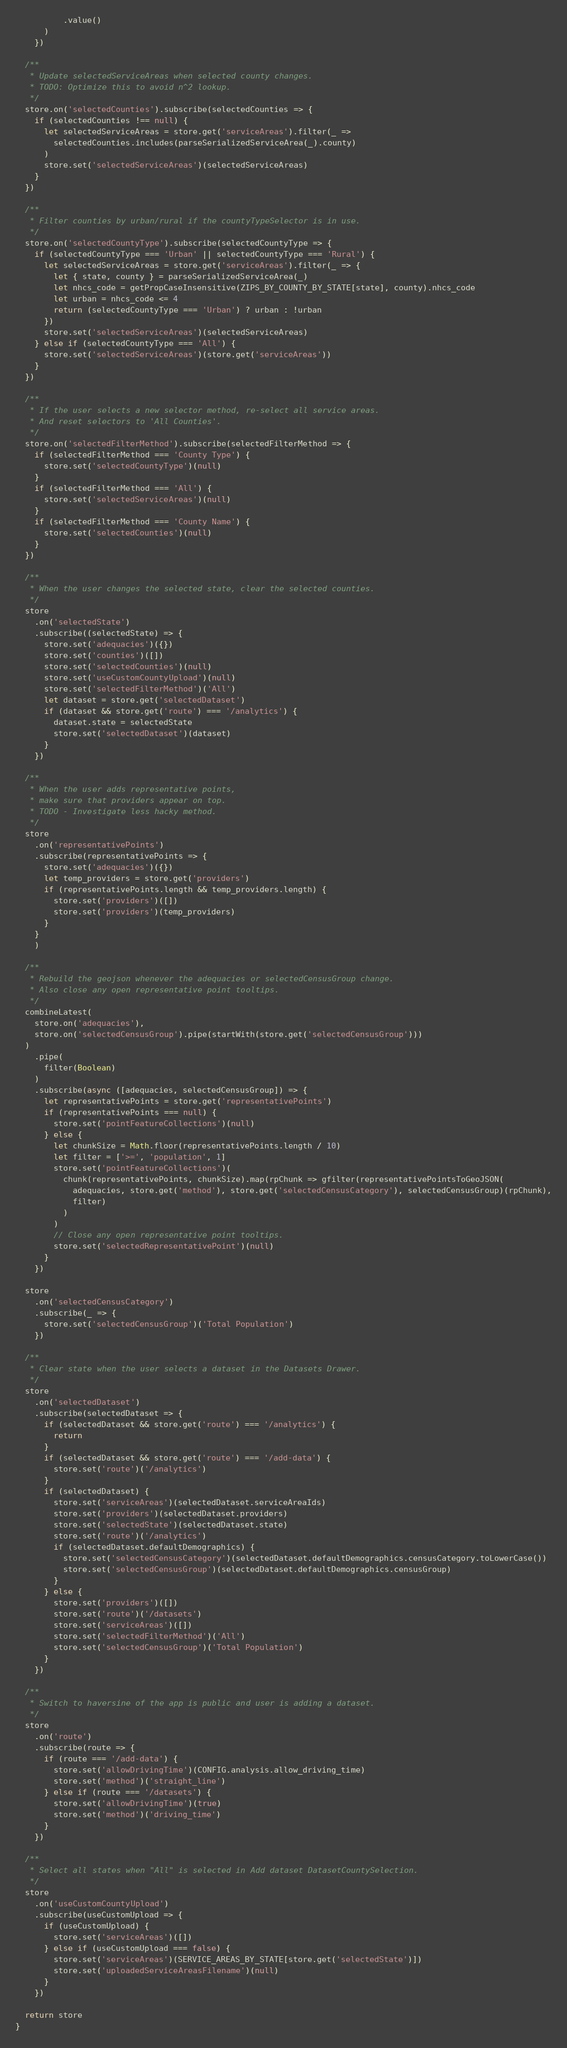Convert code to text. <code><loc_0><loc_0><loc_500><loc_500><_TypeScript_>          .value()
      )
    })

  /**
   * Update selectedServiceAreas when selected county changes.
   * TODO: Optimize this to avoid n^2 lookup.
   */
  store.on('selectedCounties').subscribe(selectedCounties => {
    if (selectedCounties !== null) {
      let selectedServiceAreas = store.get('serviceAreas').filter(_ =>
        selectedCounties.includes(parseSerializedServiceArea(_).county)
      )
      store.set('selectedServiceAreas')(selectedServiceAreas)
    }
  })

  /**
   * Filter counties by urban/rural if the countyTypeSelector is in use.
   */
  store.on('selectedCountyType').subscribe(selectedCountyType => {
    if (selectedCountyType === 'Urban' || selectedCountyType === 'Rural') {
      let selectedServiceAreas = store.get('serviceAreas').filter(_ => {
        let { state, county } = parseSerializedServiceArea(_)
        let nhcs_code = getPropCaseInsensitive(ZIPS_BY_COUNTY_BY_STATE[state], county).nhcs_code
        let urban = nhcs_code <= 4
        return (selectedCountyType === 'Urban') ? urban : !urban
      })
      store.set('selectedServiceAreas')(selectedServiceAreas)
    } else if (selectedCountyType === 'All') {
      store.set('selectedServiceAreas')(store.get('serviceAreas'))
    }
  })

  /**
   * If the user selects a new selector method, re-select all service areas.
   * And reset selectors to 'All Counties'.
   */
  store.on('selectedFilterMethod').subscribe(selectedFilterMethod => {
    if (selectedFilterMethod === 'County Type') {
      store.set('selectedCountyType')(null)
    }
    if (selectedFilterMethod === 'All') {
      store.set('selectedServiceAreas')(null)
    }
    if (selectedFilterMethod === 'County Name') {
      store.set('selectedCounties')(null)
    }
  })

  /**
   * When the user changes the selected state, clear the selected counties.
   */
  store
    .on('selectedState')
    .subscribe((selectedState) => {
      store.set('adequacies')({})
      store.set('counties')([])
      store.set('selectedCounties')(null)
      store.set('useCustomCountyUpload')(null)
      store.set('selectedFilterMethod')('All')
      let dataset = store.get('selectedDataset')
      if (dataset && store.get('route') === '/analytics') {
        dataset.state = selectedState
        store.set('selectedDataset')(dataset)
      }
    })

  /**
   * When the user adds representative points,
   * make sure that providers appear on top.
   * TODO - Investigate less hacky method.
   */
  store
    .on('representativePoints')
    .subscribe(representativePoints => {
      store.set('adequacies')({})
      let temp_providers = store.get('providers')
      if (representativePoints.length && temp_providers.length) {
        store.set('providers')([])
        store.set('providers')(temp_providers)
      }
    }
    )

  /**
   * Rebuild the geojson whenever the adequacies or selectedCensusGroup change.
   * Also close any open representative point tooltips.
   */
  combineLatest(
    store.on('adequacies'),
    store.on('selectedCensusGroup').pipe(startWith(store.get('selectedCensusGroup')))
  )
    .pipe(
      filter(Boolean)
    )
    .subscribe(async ([adequacies, selectedCensusGroup]) => {
      let representativePoints = store.get('representativePoints')
      if (representativePoints === null) {
        store.set('pointFeatureCollections')(null)
      } else {
        let chunkSize = Math.floor(representativePoints.length / 10)
        let filter = ['>=', 'population', 1]
        store.set('pointFeatureCollections')(
          chunk(representativePoints, chunkSize).map(rpChunk => gfilter(representativePointsToGeoJSON(
            adequacies, store.get('method'), store.get('selectedCensusCategory'), selectedCensusGroup)(rpChunk),
            filter)
          )
        )
        // Close any open representative point tooltips.
        store.set('selectedRepresentativePoint')(null)
      }
    })

  store
    .on('selectedCensusCategory')
    .subscribe(_ => {
      store.set('selectedCensusGroup')('Total Population')
    })

  /**
   * Clear state when the user selects a dataset in the Datasets Drawer.
   */
  store
    .on('selectedDataset')
    .subscribe(selectedDataset => {
      if (selectedDataset && store.get('route') === '/analytics') {
        return
      }
      if (selectedDataset && store.get('route') === '/add-data') {
        store.set('route')('/analytics')
      }
      if (selectedDataset) {
        store.set('serviceAreas')(selectedDataset.serviceAreaIds)
        store.set('providers')(selectedDataset.providers)
        store.set('selectedState')(selectedDataset.state)
        store.set('route')('/analytics')
        if (selectedDataset.defaultDemographics) {
          store.set('selectedCensusCategory')(selectedDataset.defaultDemographics.censusCategory.toLowerCase())
          store.set('selectedCensusGroup')(selectedDataset.defaultDemographics.censusGroup)
        }
      } else {
        store.set('providers')([])
        store.set('route')('/datasets')
        store.set('serviceAreas')([])
        store.set('selectedFilterMethod')('All')
        store.set('selectedCensusGroup')('Total Population')
      }
    })

  /**
   * Switch to haversine of the app is public and user is adding a dataset.
   */
  store
    .on('route')
    .subscribe(route => {
      if (route === '/add-data') {
        store.set('allowDrivingTime')(CONFIG.analysis.allow_driving_time)
        store.set('method')('straight_line')
      } else if (route === '/datasets') {
        store.set('allowDrivingTime')(true)
        store.set('method')('driving_time')
      }
    })

  /**
   * Select all states when "All" is selected in Add dataset DatasetCountySelection.
   */
  store
    .on('useCustomCountyUpload')
    .subscribe(useCustomUpload => {
      if (useCustomUpload) {
        store.set('serviceAreas')([])
      } else if (useCustomUpload === false) {
        store.set('serviceAreas')(SERVICE_AREAS_BY_STATE[store.get('selectedState')])
        store.set('uploadedServiceAreasFilename')(null)
      }
    })

  return store
}
</code> 